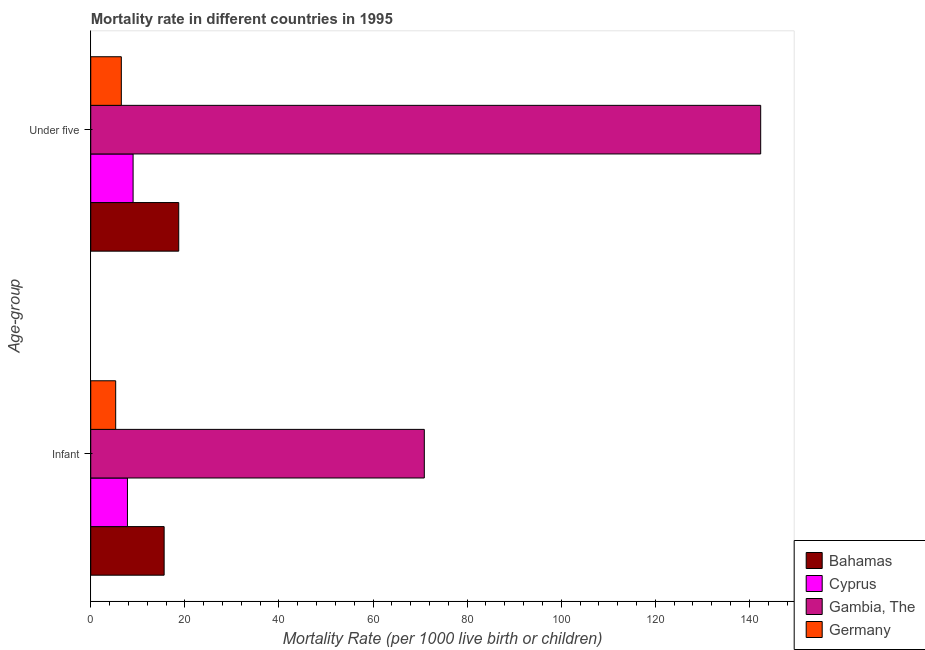How many different coloured bars are there?
Offer a terse response. 4. How many groups of bars are there?
Offer a terse response. 2. Are the number of bars on each tick of the Y-axis equal?
Your answer should be compact. Yes. How many bars are there on the 1st tick from the top?
Your response must be concise. 4. What is the label of the 2nd group of bars from the top?
Offer a terse response. Infant. What is the under-5 mortality rate in Gambia, The?
Give a very brief answer. 142.4. Across all countries, what is the maximum under-5 mortality rate?
Ensure brevity in your answer.  142.4. Across all countries, what is the minimum infant mortality rate?
Keep it short and to the point. 5.3. In which country was the under-5 mortality rate maximum?
Provide a succinct answer. Gambia, The. What is the total under-5 mortality rate in the graph?
Offer a terse response. 176.6. What is the difference between the under-5 mortality rate in Germany and the infant mortality rate in Gambia, The?
Your response must be concise. -64.4. What is the average infant mortality rate per country?
Your answer should be compact. 24.9. What is the difference between the infant mortality rate and under-5 mortality rate in Cyprus?
Provide a short and direct response. -1.2. What is the ratio of the infant mortality rate in Germany to that in Cyprus?
Your answer should be very brief. 0.68. In how many countries, is the infant mortality rate greater than the average infant mortality rate taken over all countries?
Your answer should be compact. 1. What does the 1st bar from the top in Under five represents?
Offer a very short reply. Germany. What does the 3rd bar from the bottom in Infant represents?
Your answer should be very brief. Gambia, The. What is the difference between two consecutive major ticks on the X-axis?
Offer a very short reply. 20. Are the values on the major ticks of X-axis written in scientific E-notation?
Your response must be concise. No. Does the graph contain grids?
Provide a succinct answer. No. Where does the legend appear in the graph?
Offer a terse response. Bottom right. What is the title of the graph?
Ensure brevity in your answer.  Mortality rate in different countries in 1995. Does "Low income" appear as one of the legend labels in the graph?
Give a very brief answer. No. What is the label or title of the X-axis?
Your response must be concise. Mortality Rate (per 1000 live birth or children). What is the label or title of the Y-axis?
Offer a very short reply. Age-group. What is the Mortality Rate (per 1000 live birth or children) of Bahamas in Infant?
Keep it short and to the point. 15.6. What is the Mortality Rate (per 1000 live birth or children) in Gambia, The in Infant?
Your answer should be compact. 70.9. What is the Mortality Rate (per 1000 live birth or children) in Cyprus in Under five?
Provide a succinct answer. 9. What is the Mortality Rate (per 1000 live birth or children) of Gambia, The in Under five?
Offer a very short reply. 142.4. What is the Mortality Rate (per 1000 live birth or children) of Germany in Under five?
Keep it short and to the point. 6.5. Across all Age-group, what is the maximum Mortality Rate (per 1000 live birth or children) in Bahamas?
Make the answer very short. 18.7. Across all Age-group, what is the maximum Mortality Rate (per 1000 live birth or children) in Cyprus?
Provide a succinct answer. 9. Across all Age-group, what is the maximum Mortality Rate (per 1000 live birth or children) of Gambia, The?
Make the answer very short. 142.4. Across all Age-group, what is the maximum Mortality Rate (per 1000 live birth or children) in Germany?
Your answer should be compact. 6.5. Across all Age-group, what is the minimum Mortality Rate (per 1000 live birth or children) in Bahamas?
Keep it short and to the point. 15.6. Across all Age-group, what is the minimum Mortality Rate (per 1000 live birth or children) of Gambia, The?
Your answer should be very brief. 70.9. What is the total Mortality Rate (per 1000 live birth or children) in Bahamas in the graph?
Your answer should be very brief. 34.3. What is the total Mortality Rate (per 1000 live birth or children) in Cyprus in the graph?
Make the answer very short. 16.8. What is the total Mortality Rate (per 1000 live birth or children) in Gambia, The in the graph?
Keep it short and to the point. 213.3. What is the difference between the Mortality Rate (per 1000 live birth or children) in Bahamas in Infant and that in Under five?
Ensure brevity in your answer.  -3.1. What is the difference between the Mortality Rate (per 1000 live birth or children) in Cyprus in Infant and that in Under five?
Offer a terse response. -1.2. What is the difference between the Mortality Rate (per 1000 live birth or children) in Gambia, The in Infant and that in Under five?
Provide a short and direct response. -71.5. What is the difference between the Mortality Rate (per 1000 live birth or children) of Germany in Infant and that in Under five?
Your response must be concise. -1.2. What is the difference between the Mortality Rate (per 1000 live birth or children) of Bahamas in Infant and the Mortality Rate (per 1000 live birth or children) of Gambia, The in Under five?
Your answer should be compact. -126.8. What is the difference between the Mortality Rate (per 1000 live birth or children) of Cyprus in Infant and the Mortality Rate (per 1000 live birth or children) of Gambia, The in Under five?
Your answer should be very brief. -134.6. What is the difference between the Mortality Rate (per 1000 live birth or children) in Cyprus in Infant and the Mortality Rate (per 1000 live birth or children) in Germany in Under five?
Provide a succinct answer. 1.3. What is the difference between the Mortality Rate (per 1000 live birth or children) in Gambia, The in Infant and the Mortality Rate (per 1000 live birth or children) in Germany in Under five?
Offer a terse response. 64.4. What is the average Mortality Rate (per 1000 live birth or children) in Bahamas per Age-group?
Make the answer very short. 17.15. What is the average Mortality Rate (per 1000 live birth or children) in Cyprus per Age-group?
Make the answer very short. 8.4. What is the average Mortality Rate (per 1000 live birth or children) of Gambia, The per Age-group?
Your answer should be very brief. 106.65. What is the average Mortality Rate (per 1000 live birth or children) of Germany per Age-group?
Your answer should be compact. 5.9. What is the difference between the Mortality Rate (per 1000 live birth or children) in Bahamas and Mortality Rate (per 1000 live birth or children) in Gambia, The in Infant?
Ensure brevity in your answer.  -55.3. What is the difference between the Mortality Rate (per 1000 live birth or children) of Bahamas and Mortality Rate (per 1000 live birth or children) of Germany in Infant?
Your answer should be compact. 10.3. What is the difference between the Mortality Rate (per 1000 live birth or children) in Cyprus and Mortality Rate (per 1000 live birth or children) in Gambia, The in Infant?
Provide a short and direct response. -63.1. What is the difference between the Mortality Rate (per 1000 live birth or children) of Cyprus and Mortality Rate (per 1000 live birth or children) of Germany in Infant?
Make the answer very short. 2.5. What is the difference between the Mortality Rate (per 1000 live birth or children) in Gambia, The and Mortality Rate (per 1000 live birth or children) in Germany in Infant?
Keep it short and to the point. 65.6. What is the difference between the Mortality Rate (per 1000 live birth or children) of Bahamas and Mortality Rate (per 1000 live birth or children) of Gambia, The in Under five?
Make the answer very short. -123.7. What is the difference between the Mortality Rate (per 1000 live birth or children) of Cyprus and Mortality Rate (per 1000 live birth or children) of Gambia, The in Under five?
Provide a succinct answer. -133.4. What is the difference between the Mortality Rate (per 1000 live birth or children) of Gambia, The and Mortality Rate (per 1000 live birth or children) of Germany in Under five?
Keep it short and to the point. 135.9. What is the ratio of the Mortality Rate (per 1000 live birth or children) in Bahamas in Infant to that in Under five?
Give a very brief answer. 0.83. What is the ratio of the Mortality Rate (per 1000 live birth or children) in Cyprus in Infant to that in Under five?
Your response must be concise. 0.87. What is the ratio of the Mortality Rate (per 1000 live birth or children) in Gambia, The in Infant to that in Under five?
Your response must be concise. 0.5. What is the ratio of the Mortality Rate (per 1000 live birth or children) of Germany in Infant to that in Under five?
Your answer should be compact. 0.82. What is the difference between the highest and the second highest Mortality Rate (per 1000 live birth or children) in Cyprus?
Your answer should be very brief. 1.2. What is the difference between the highest and the second highest Mortality Rate (per 1000 live birth or children) of Gambia, The?
Your answer should be very brief. 71.5. What is the difference between the highest and the lowest Mortality Rate (per 1000 live birth or children) of Bahamas?
Your answer should be very brief. 3.1. What is the difference between the highest and the lowest Mortality Rate (per 1000 live birth or children) of Gambia, The?
Provide a succinct answer. 71.5. 